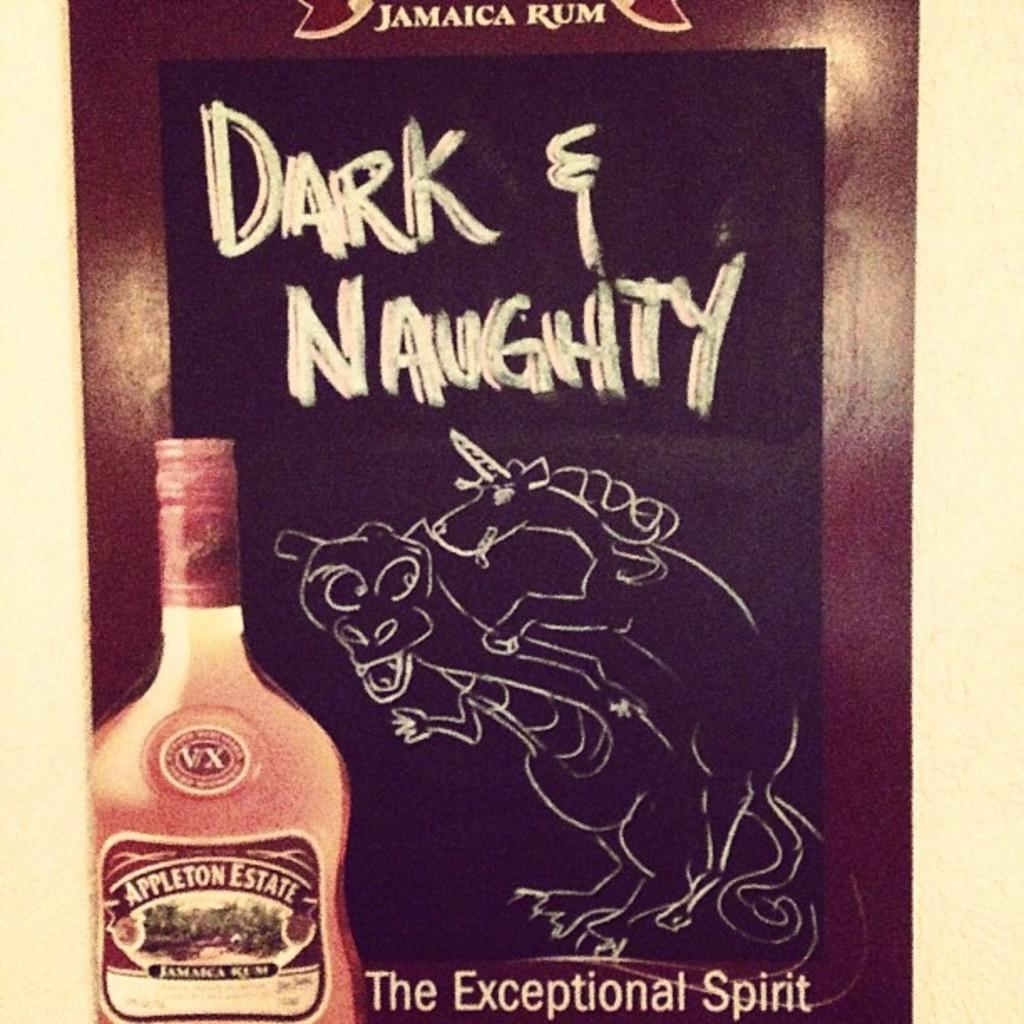Provide a one-sentence caption for the provided image. An ad for Jamaican Rum named Appleton Estate. 